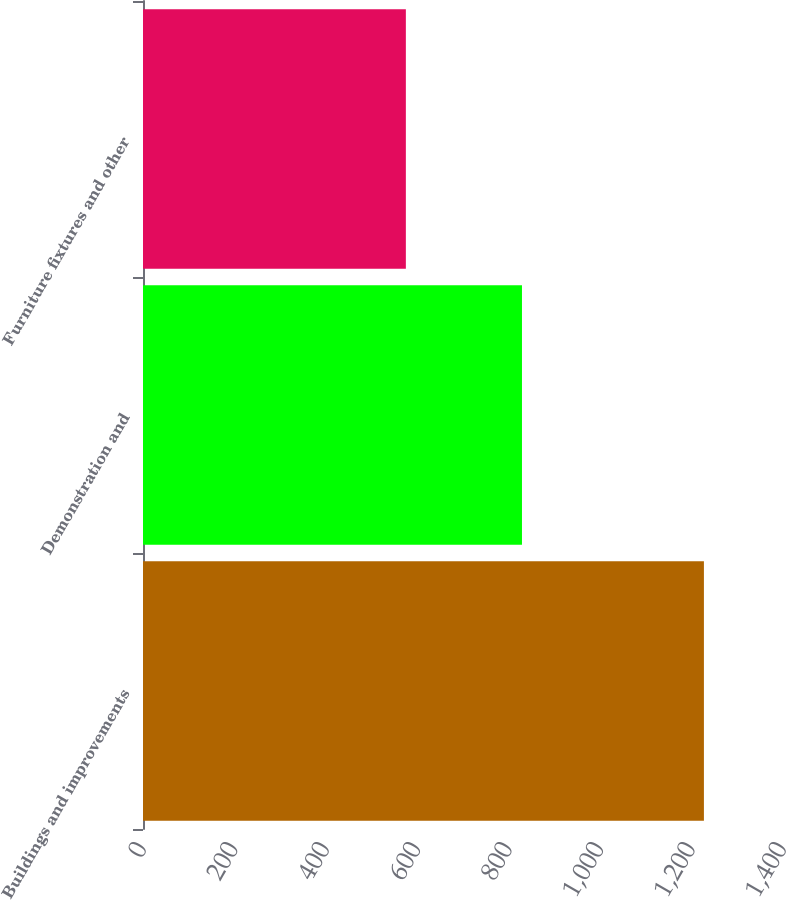<chart> <loc_0><loc_0><loc_500><loc_500><bar_chart><fcel>Buildings and improvements<fcel>Demonstration and<fcel>Furniture fixtures and other<nl><fcel>1227<fcel>829<fcel>575<nl></chart> 